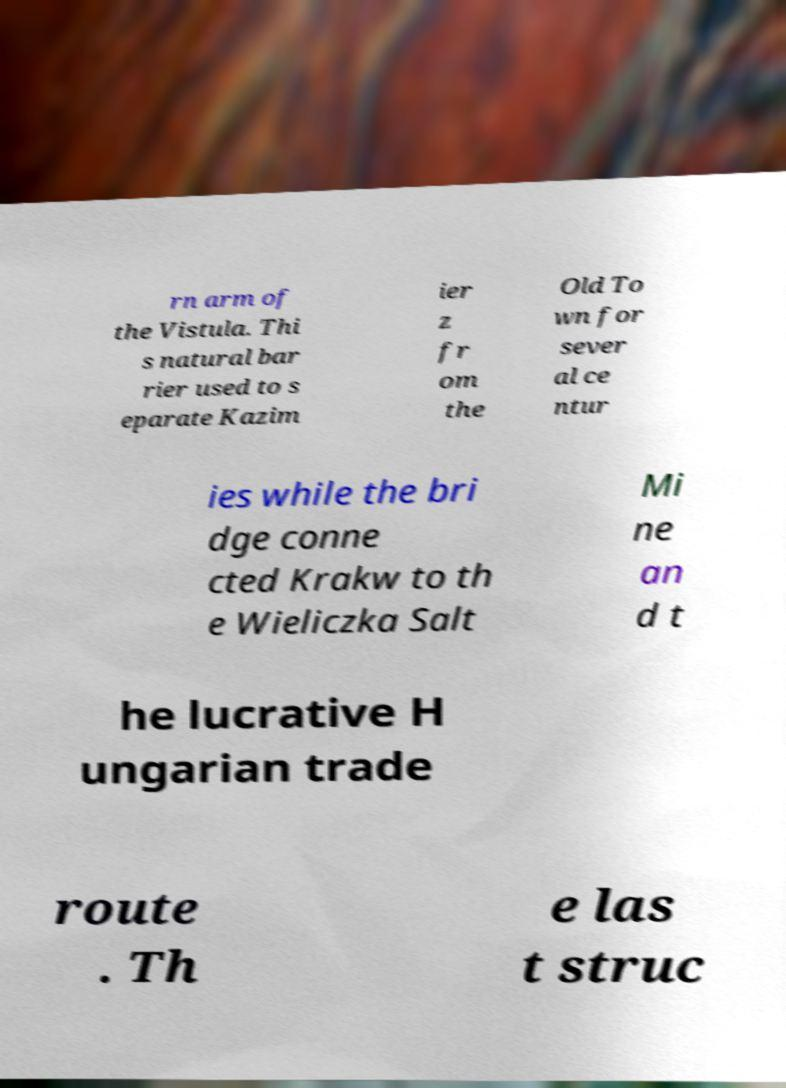Please read and relay the text visible in this image. What does it say? rn arm of the Vistula. Thi s natural bar rier used to s eparate Kazim ier z fr om the Old To wn for sever al ce ntur ies while the bri dge conne cted Krakw to th e Wieliczka Salt Mi ne an d t he lucrative H ungarian trade route . Th e las t struc 